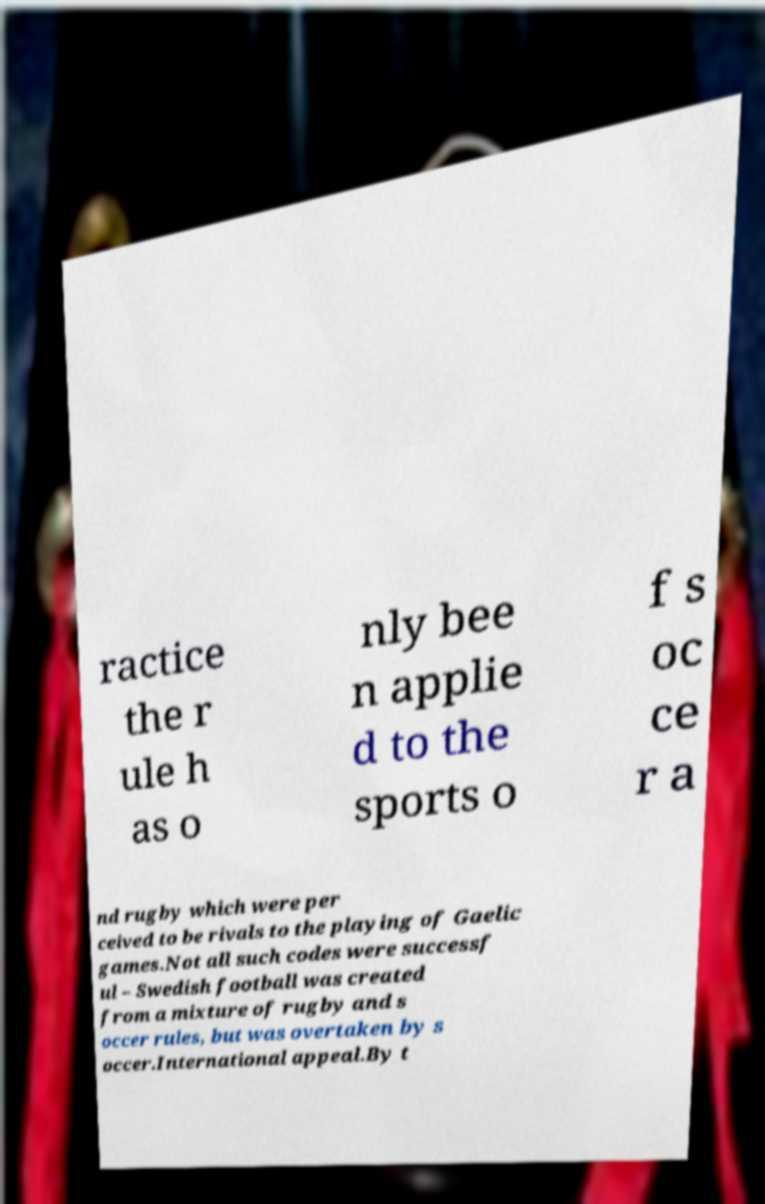Can you read and provide the text displayed in the image?This photo seems to have some interesting text. Can you extract and type it out for me? ractice the r ule h as o nly bee n applie d to the sports o f s oc ce r a nd rugby which were per ceived to be rivals to the playing of Gaelic games.Not all such codes were successf ul – Swedish football was created from a mixture of rugby and s occer rules, but was overtaken by s occer.International appeal.By t 